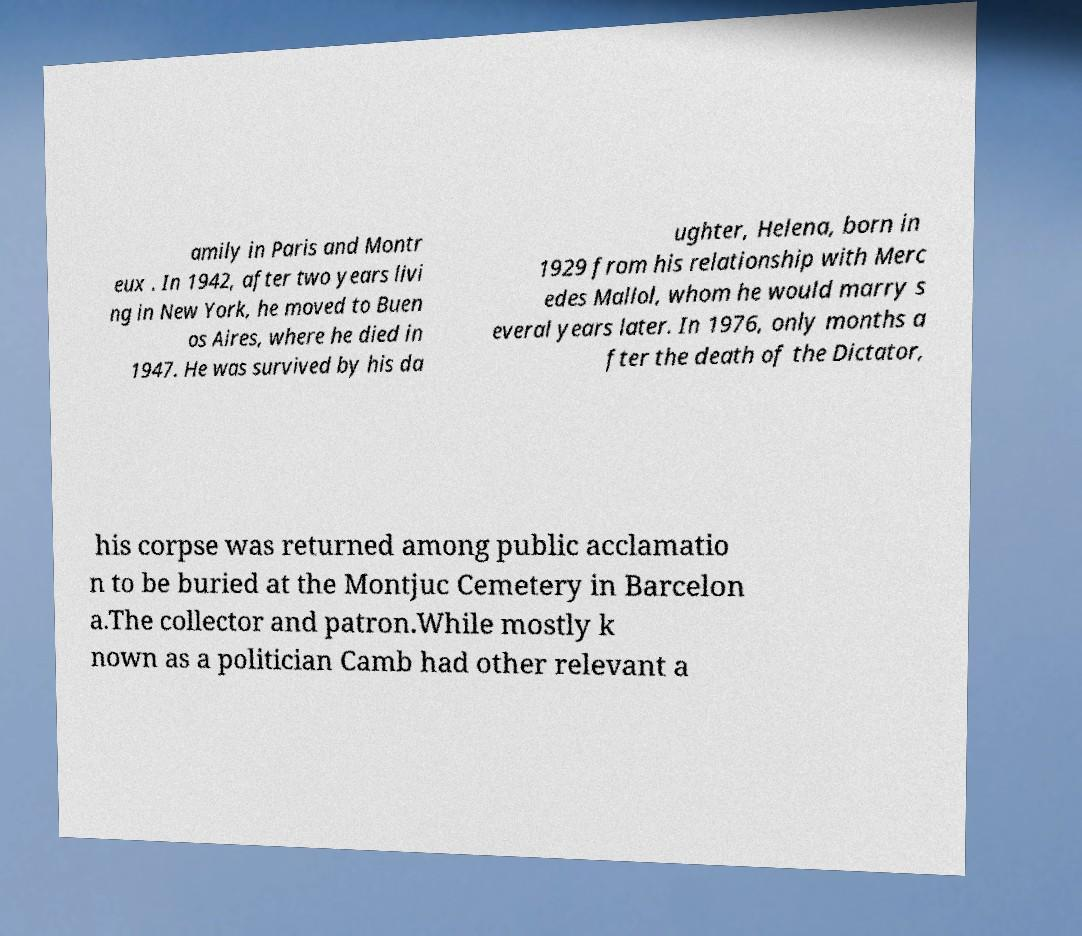Could you extract and type out the text from this image? amily in Paris and Montr eux . In 1942, after two years livi ng in New York, he moved to Buen os Aires, where he died in 1947. He was survived by his da ughter, Helena, born in 1929 from his relationship with Merc edes Mallol, whom he would marry s everal years later. In 1976, only months a fter the death of the Dictator, his corpse was returned among public acclamatio n to be buried at the Montjuc Cemetery in Barcelon a.The collector and patron.While mostly k nown as a politician Camb had other relevant a 